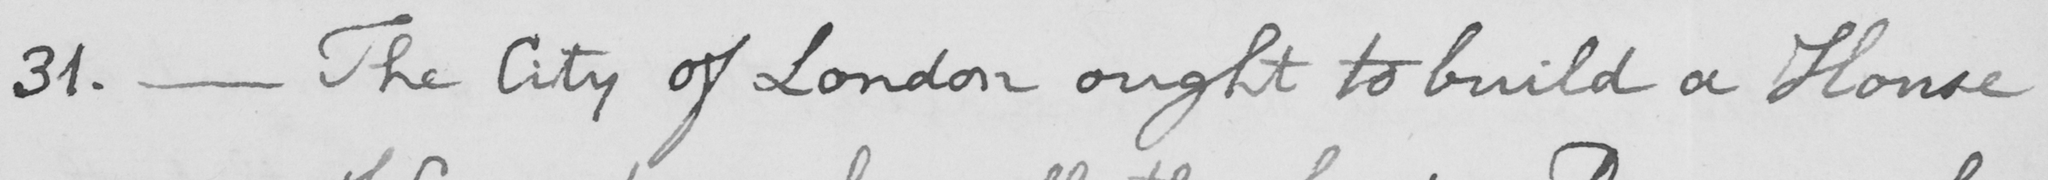Can you read and transcribe this handwriting? 31. _ The City of London ought to build a House 